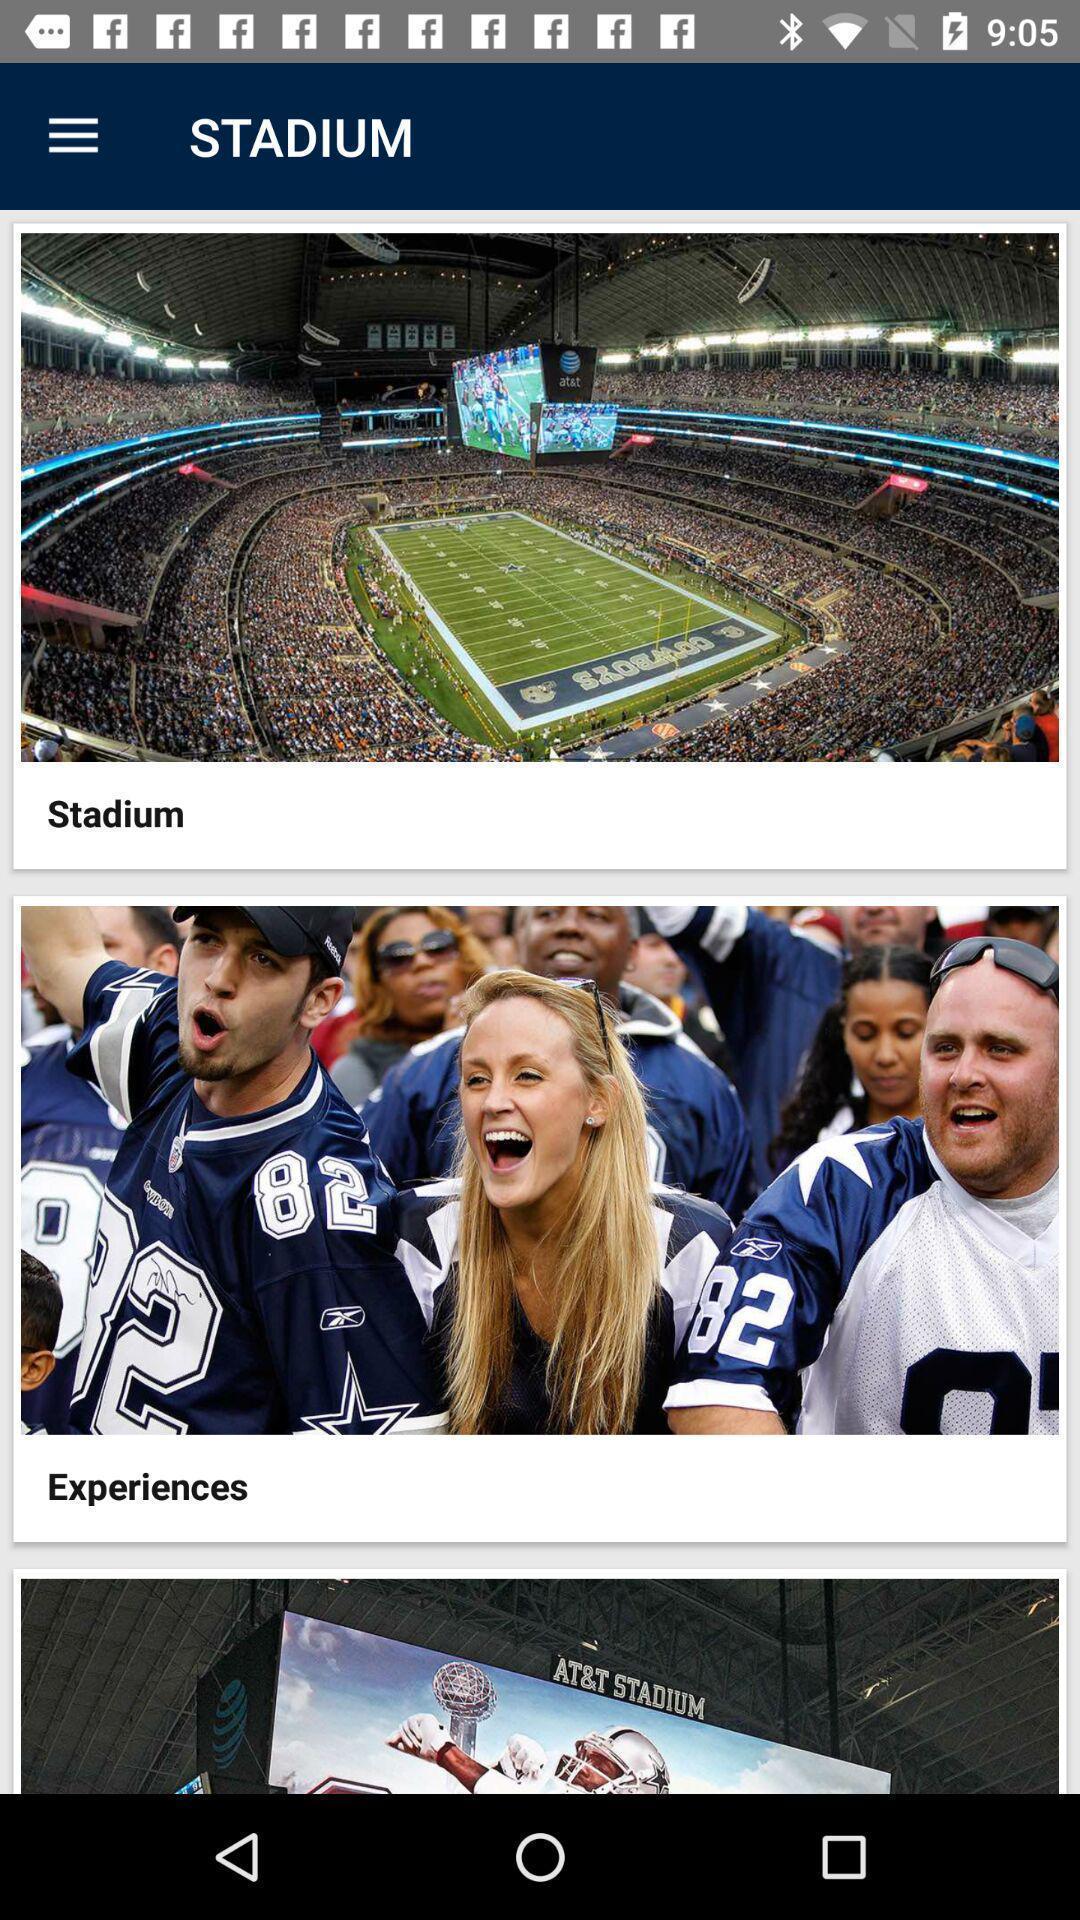Describe the key features of this screenshot. Page showing different options on a gaming app. 